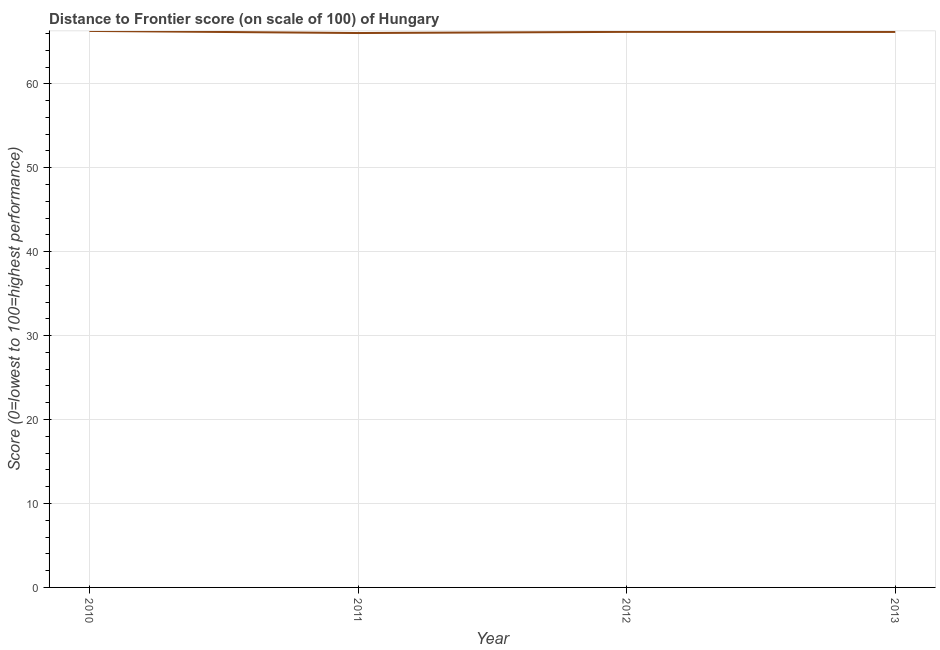What is the distance to frontier score in 2011?
Make the answer very short. 66.05. Across all years, what is the maximum distance to frontier score?
Your answer should be compact. 66.3. Across all years, what is the minimum distance to frontier score?
Give a very brief answer. 66.05. What is the sum of the distance to frontier score?
Provide a short and direct response. 264.72. What is the difference between the distance to frontier score in 2012 and 2013?
Your response must be concise. 0.01. What is the average distance to frontier score per year?
Provide a succinct answer. 66.18. What is the median distance to frontier score?
Give a very brief answer. 66.19. Do a majority of the years between 2010 and 2012 (inclusive) have distance to frontier score greater than 42 ?
Keep it short and to the point. Yes. What is the ratio of the distance to frontier score in 2012 to that in 2013?
Offer a terse response. 1. Is the distance to frontier score in 2011 less than that in 2013?
Keep it short and to the point. Yes. Is the difference between the distance to frontier score in 2011 and 2012 greater than the difference between any two years?
Keep it short and to the point. No. What is the difference between the highest and the second highest distance to frontier score?
Your answer should be compact. 0.11. Is the sum of the distance to frontier score in 2010 and 2013 greater than the maximum distance to frontier score across all years?
Provide a succinct answer. Yes. In how many years, is the distance to frontier score greater than the average distance to frontier score taken over all years?
Offer a very short reply. 2. How many lines are there?
Your answer should be very brief. 1. Are the values on the major ticks of Y-axis written in scientific E-notation?
Keep it short and to the point. No. Does the graph contain grids?
Ensure brevity in your answer.  Yes. What is the title of the graph?
Provide a succinct answer. Distance to Frontier score (on scale of 100) of Hungary. What is the label or title of the X-axis?
Your response must be concise. Year. What is the label or title of the Y-axis?
Your response must be concise. Score (0=lowest to 100=highest performance). What is the Score (0=lowest to 100=highest performance) in 2010?
Your response must be concise. 66.3. What is the Score (0=lowest to 100=highest performance) of 2011?
Offer a terse response. 66.05. What is the Score (0=lowest to 100=highest performance) in 2012?
Offer a very short reply. 66.19. What is the Score (0=lowest to 100=highest performance) of 2013?
Make the answer very short. 66.18. What is the difference between the Score (0=lowest to 100=highest performance) in 2010 and 2011?
Give a very brief answer. 0.25. What is the difference between the Score (0=lowest to 100=highest performance) in 2010 and 2012?
Provide a short and direct response. 0.11. What is the difference between the Score (0=lowest to 100=highest performance) in 2010 and 2013?
Provide a succinct answer. 0.12. What is the difference between the Score (0=lowest to 100=highest performance) in 2011 and 2012?
Your answer should be compact. -0.14. What is the difference between the Score (0=lowest to 100=highest performance) in 2011 and 2013?
Give a very brief answer. -0.13. What is the ratio of the Score (0=lowest to 100=highest performance) in 2010 to that in 2012?
Give a very brief answer. 1. What is the ratio of the Score (0=lowest to 100=highest performance) in 2010 to that in 2013?
Your answer should be compact. 1. What is the ratio of the Score (0=lowest to 100=highest performance) in 2011 to that in 2013?
Your answer should be very brief. 1. 